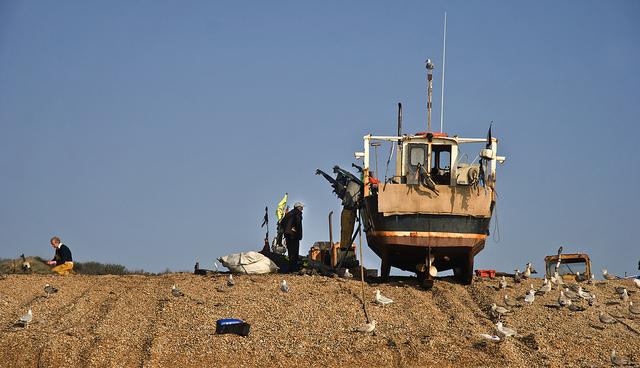Is that a boat?
Write a very short answer. Yes. Is there debris?
Write a very short answer. Yes. Why have all these birds gathered?
Give a very brief answer. For food. 